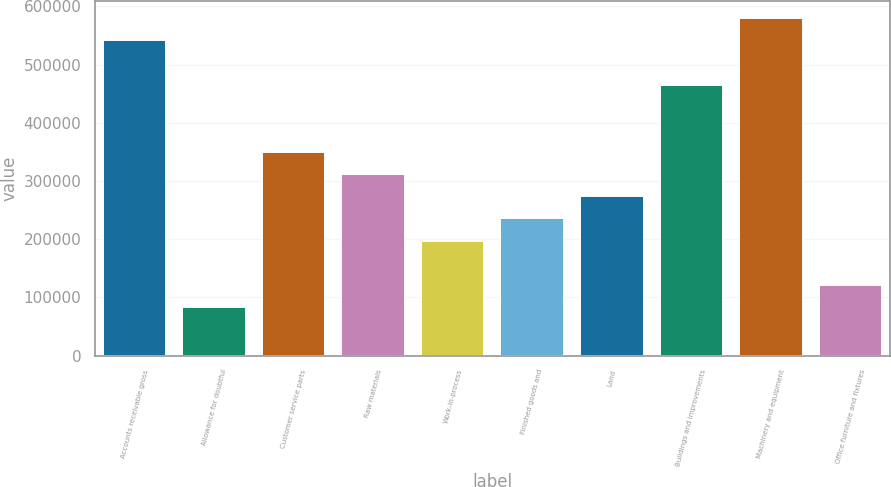Convert chart to OTSL. <chart><loc_0><loc_0><loc_500><loc_500><bar_chart><fcel>Accounts receivable gross<fcel>Allowance for doubtful<fcel>Customer service parts<fcel>Raw materials<fcel>Work-in-process<fcel>Finished goods and<fcel>Land<fcel>Buildings and improvements<fcel>Machinery and equipment<fcel>Office furniture and fixtures<nl><fcel>541278<fcel>82704.8<fcel>350206<fcel>311991<fcel>197348<fcel>235562<fcel>273777<fcel>464849<fcel>579492<fcel>120919<nl></chart> 